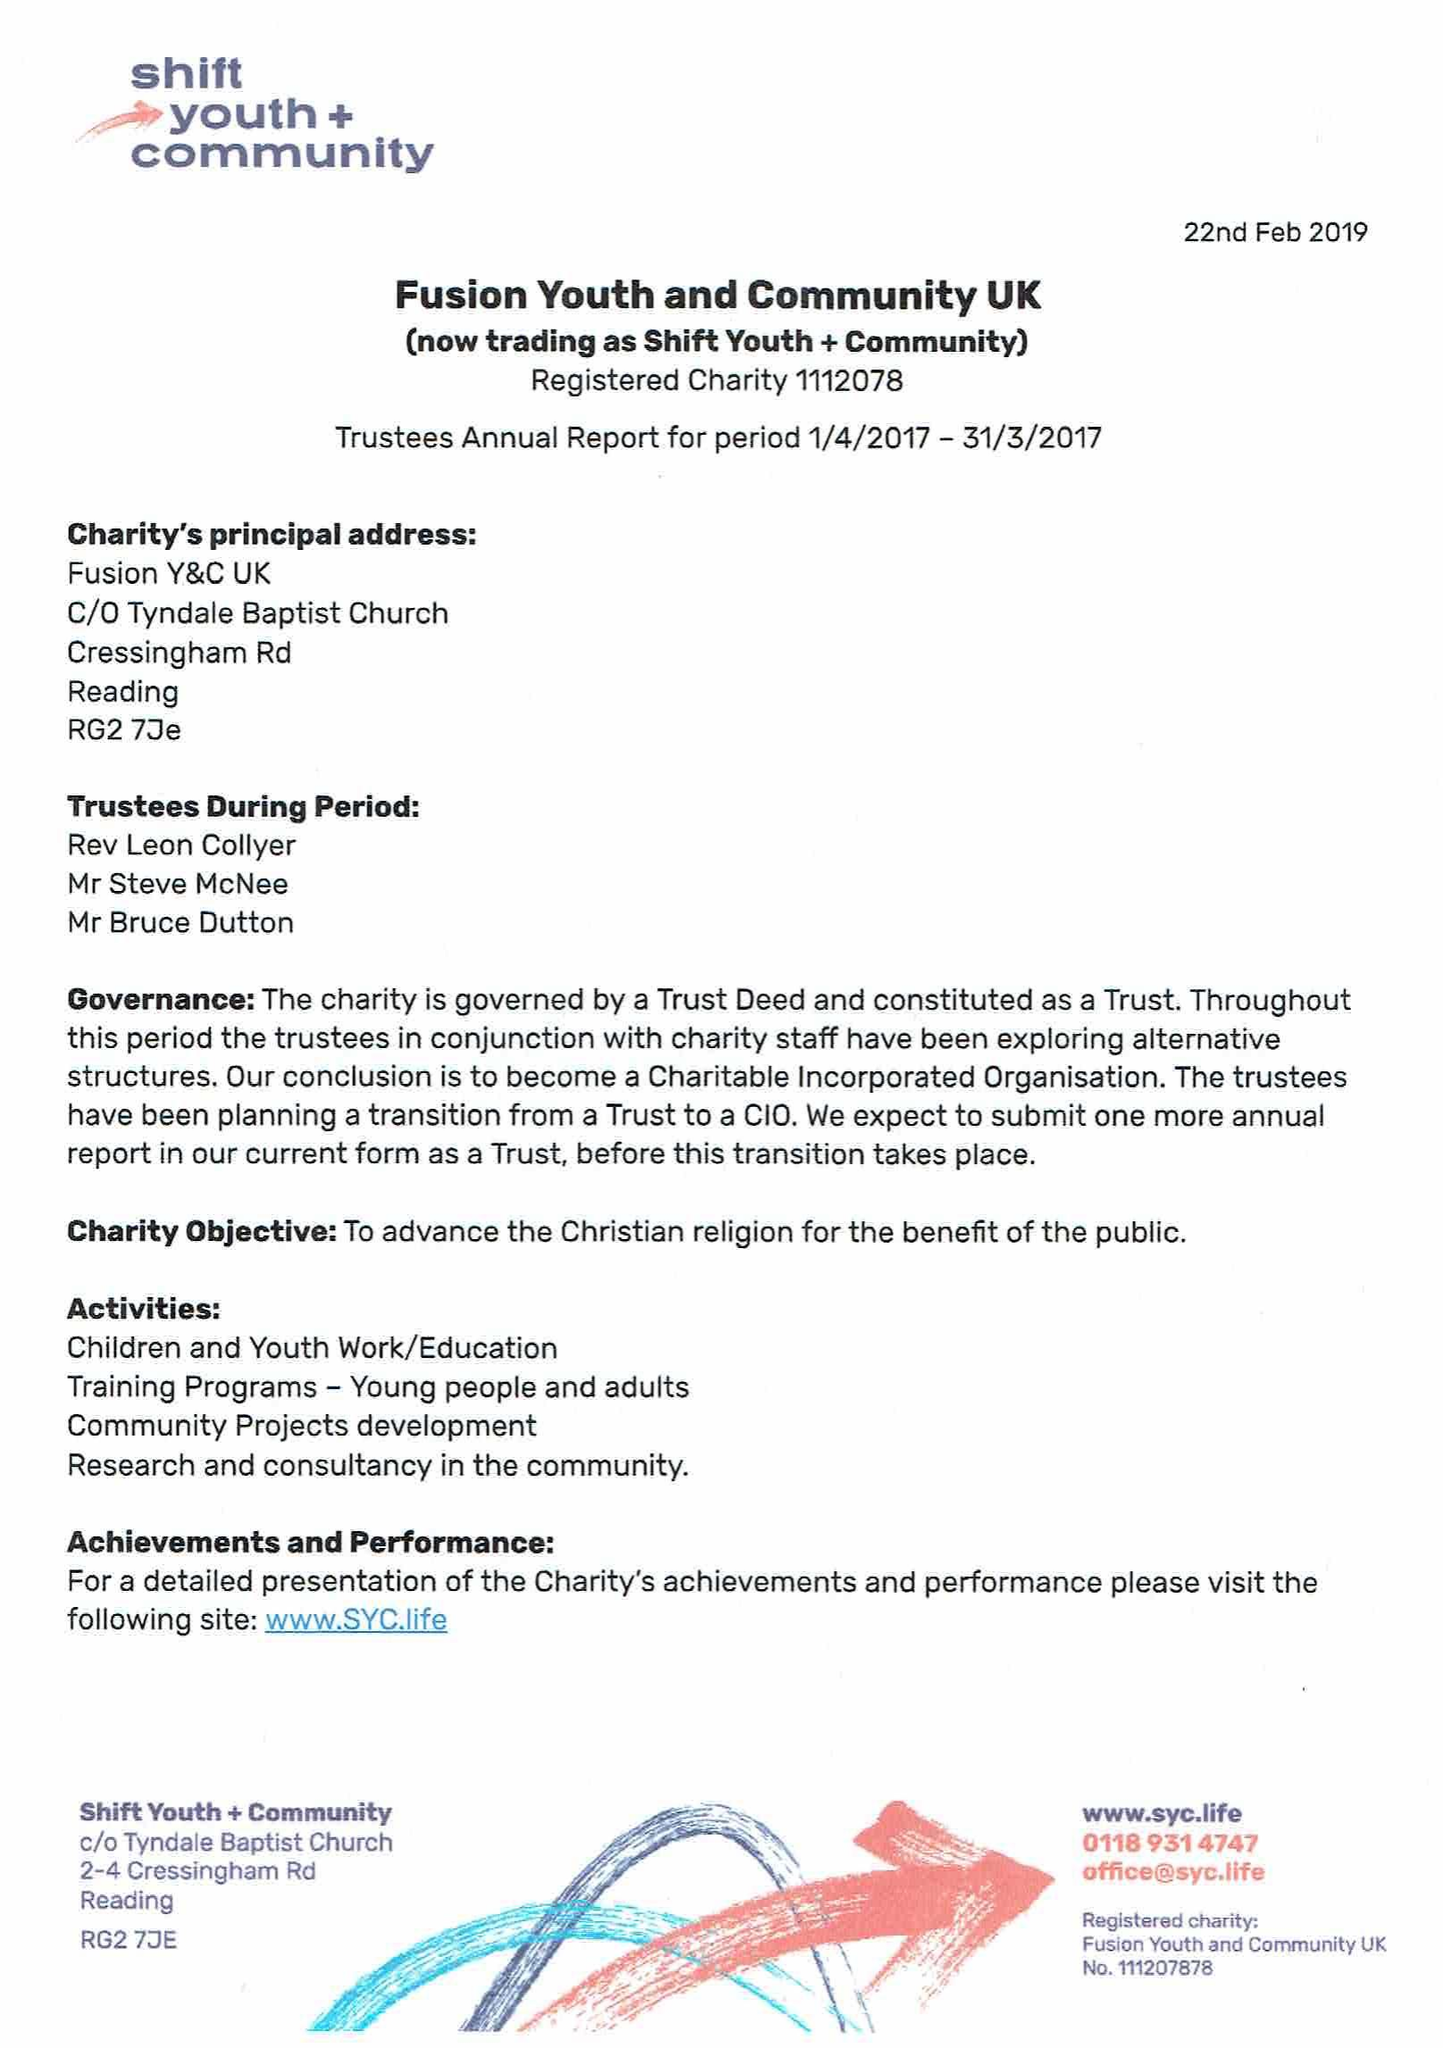What is the value for the charity_number?
Answer the question using a single word or phrase. 1112078 